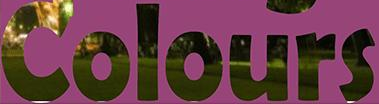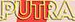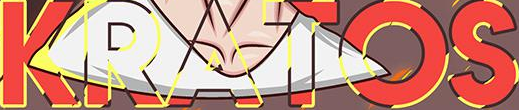Read the text content from these images in order, separated by a semicolon. Colours; PUTRA; KRATOS 